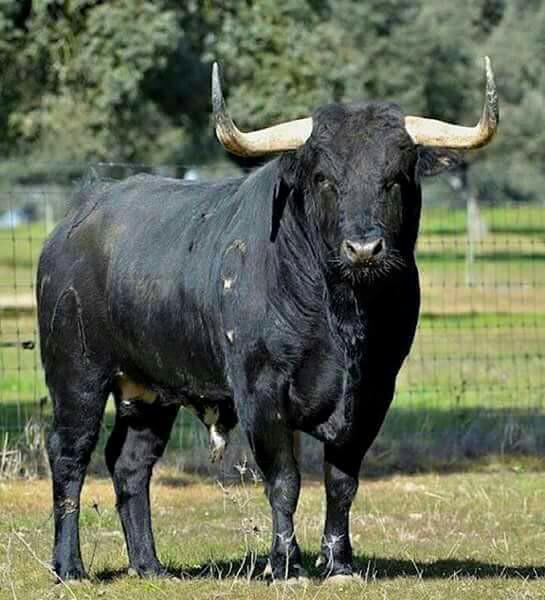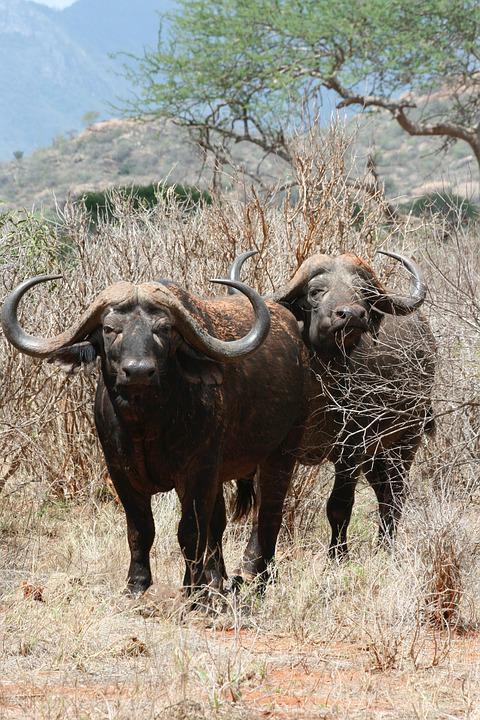The first image is the image on the left, the second image is the image on the right. Analyze the images presented: Is the assertion "There are exactly three animals." valid? Answer yes or no. Yes. 